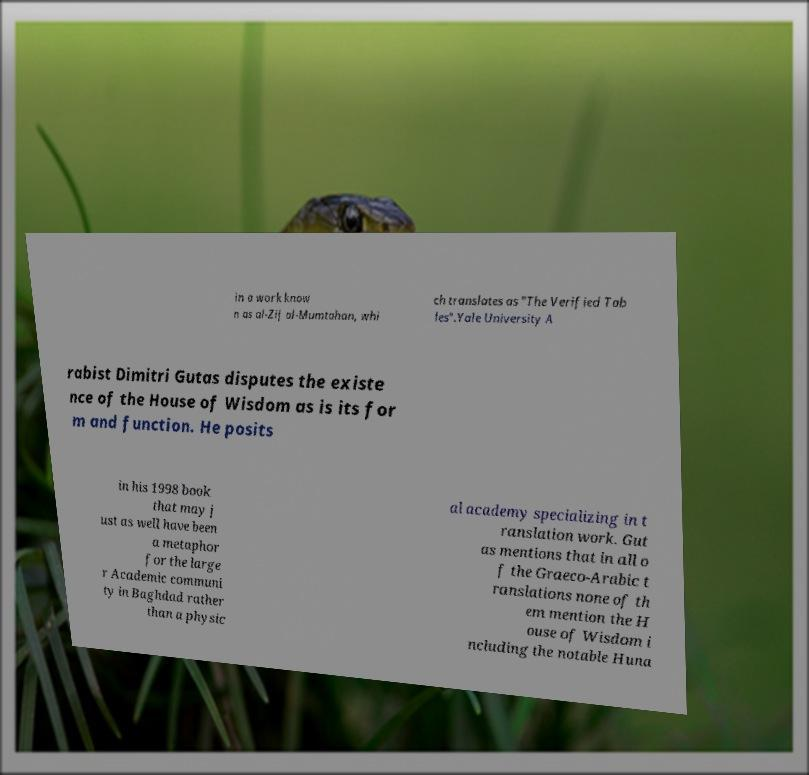There's text embedded in this image that I need extracted. Can you transcribe it verbatim? in a work know n as al-Zij al-Mumtahan, whi ch translates as "The Verified Tab les".Yale University A rabist Dimitri Gutas disputes the existe nce of the House of Wisdom as is its for m and function. He posits in his 1998 book that may j ust as well have been a metaphor for the large r Academic communi ty in Baghdad rather than a physic al academy specializing in t ranslation work. Gut as mentions that in all o f the Graeco-Arabic t ranslations none of th em mention the H ouse of Wisdom i ncluding the notable Huna 